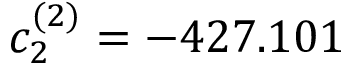<formula> <loc_0><loc_0><loc_500><loc_500>c _ { 2 } ^ { ( 2 ) } = - 4 2 7 . 1 0 1</formula> 